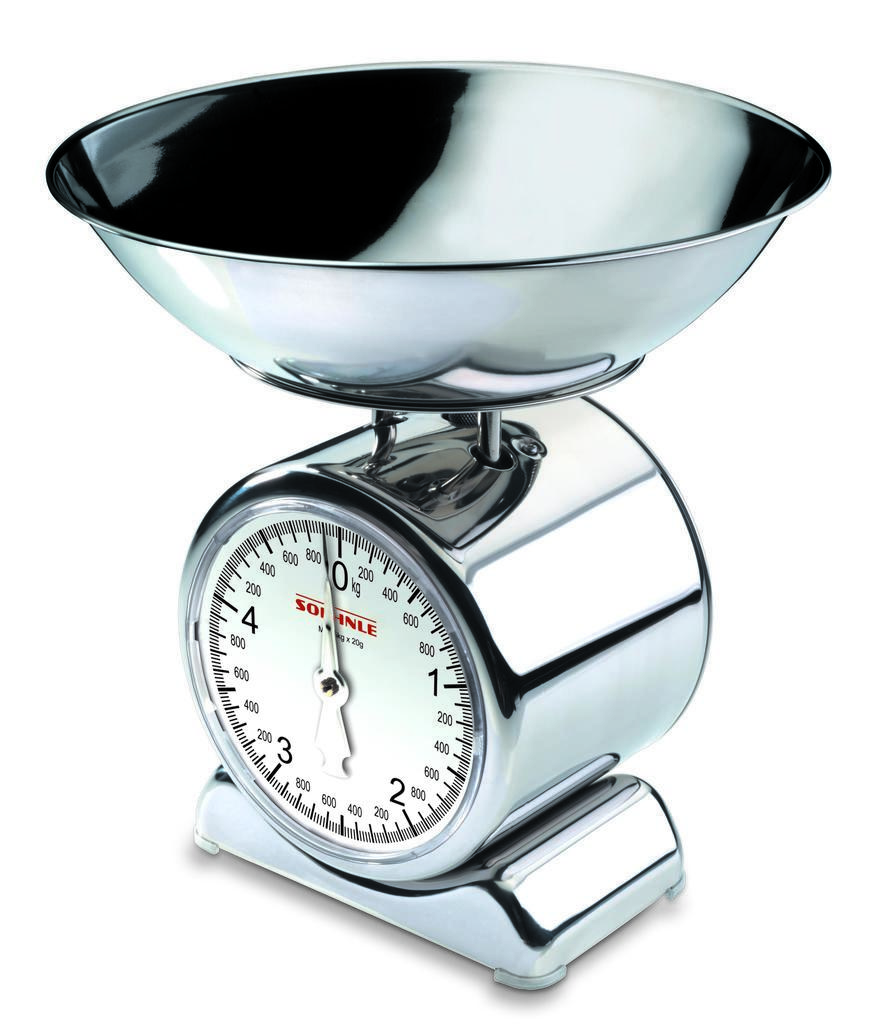What brand of scale is this?
Offer a terse response. Soehnle. What is one number on the scale?
Make the answer very short. 0. 